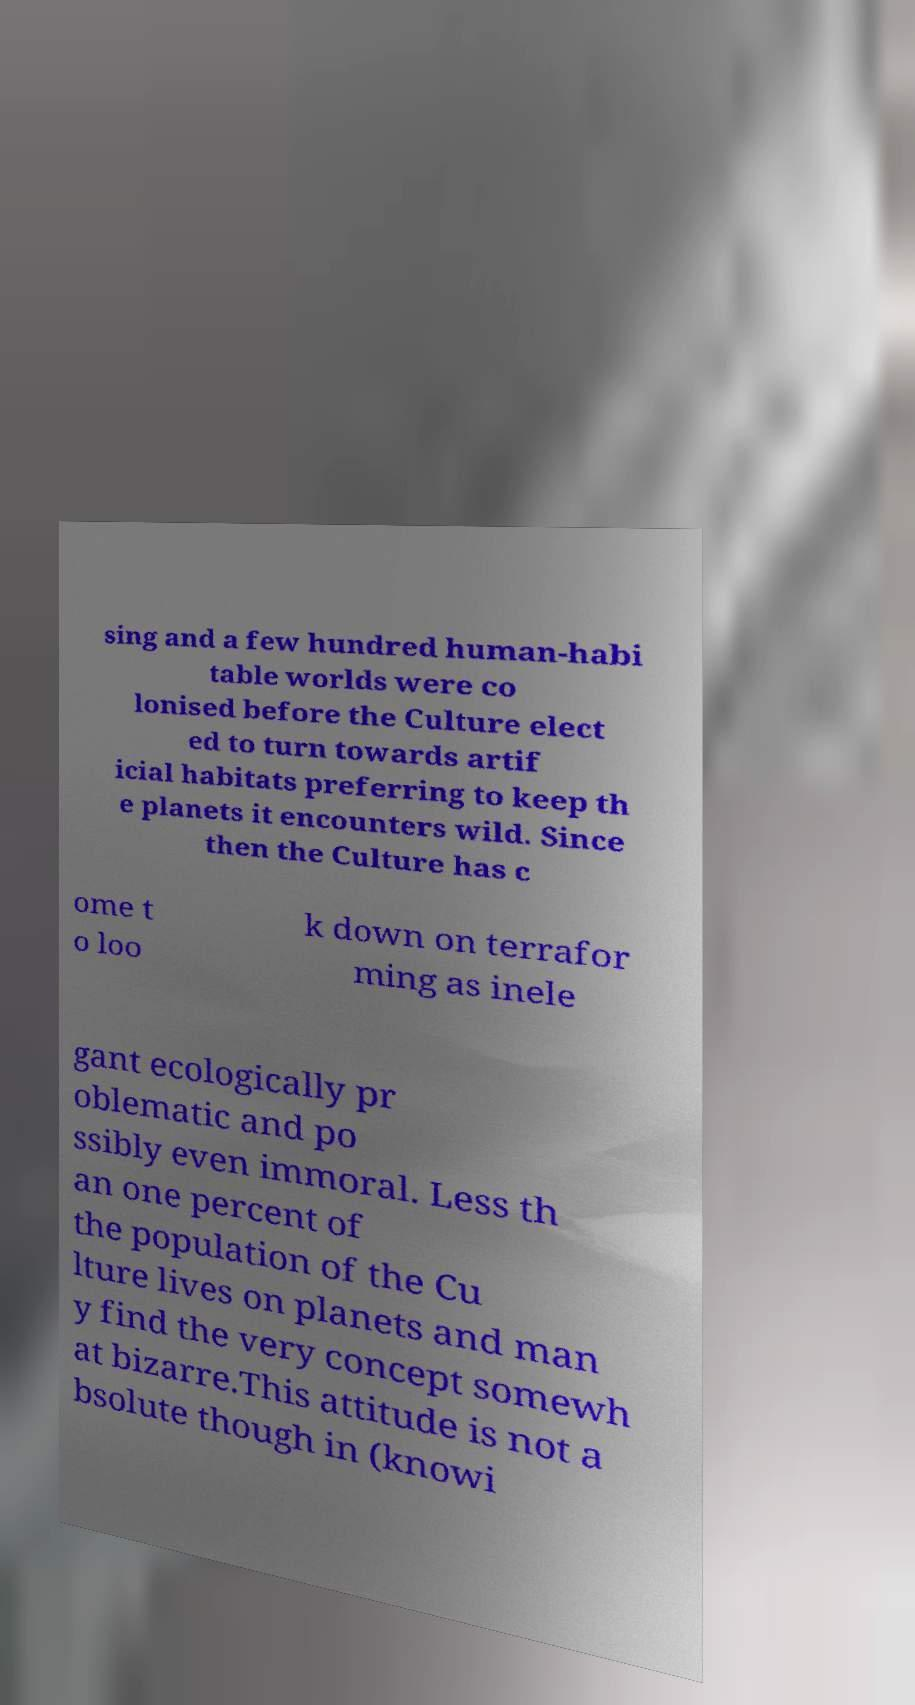Can you accurately transcribe the text from the provided image for me? sing and a few hundred human-habi table worlds were co lonised before the Culture elect ed to turn towards artif icial habitats preferring to keep th e planets it encounters wild. Since then the Culture has c ome t o loo k down on terrafor ming as inele gant ecologically pr oblematic and po ssibly even immoral. Less th an one percent of the population of the Cu lture lives on planets and man y find the very concept somewh at bizarre.This attitude is not a bsolute though in (knowi 